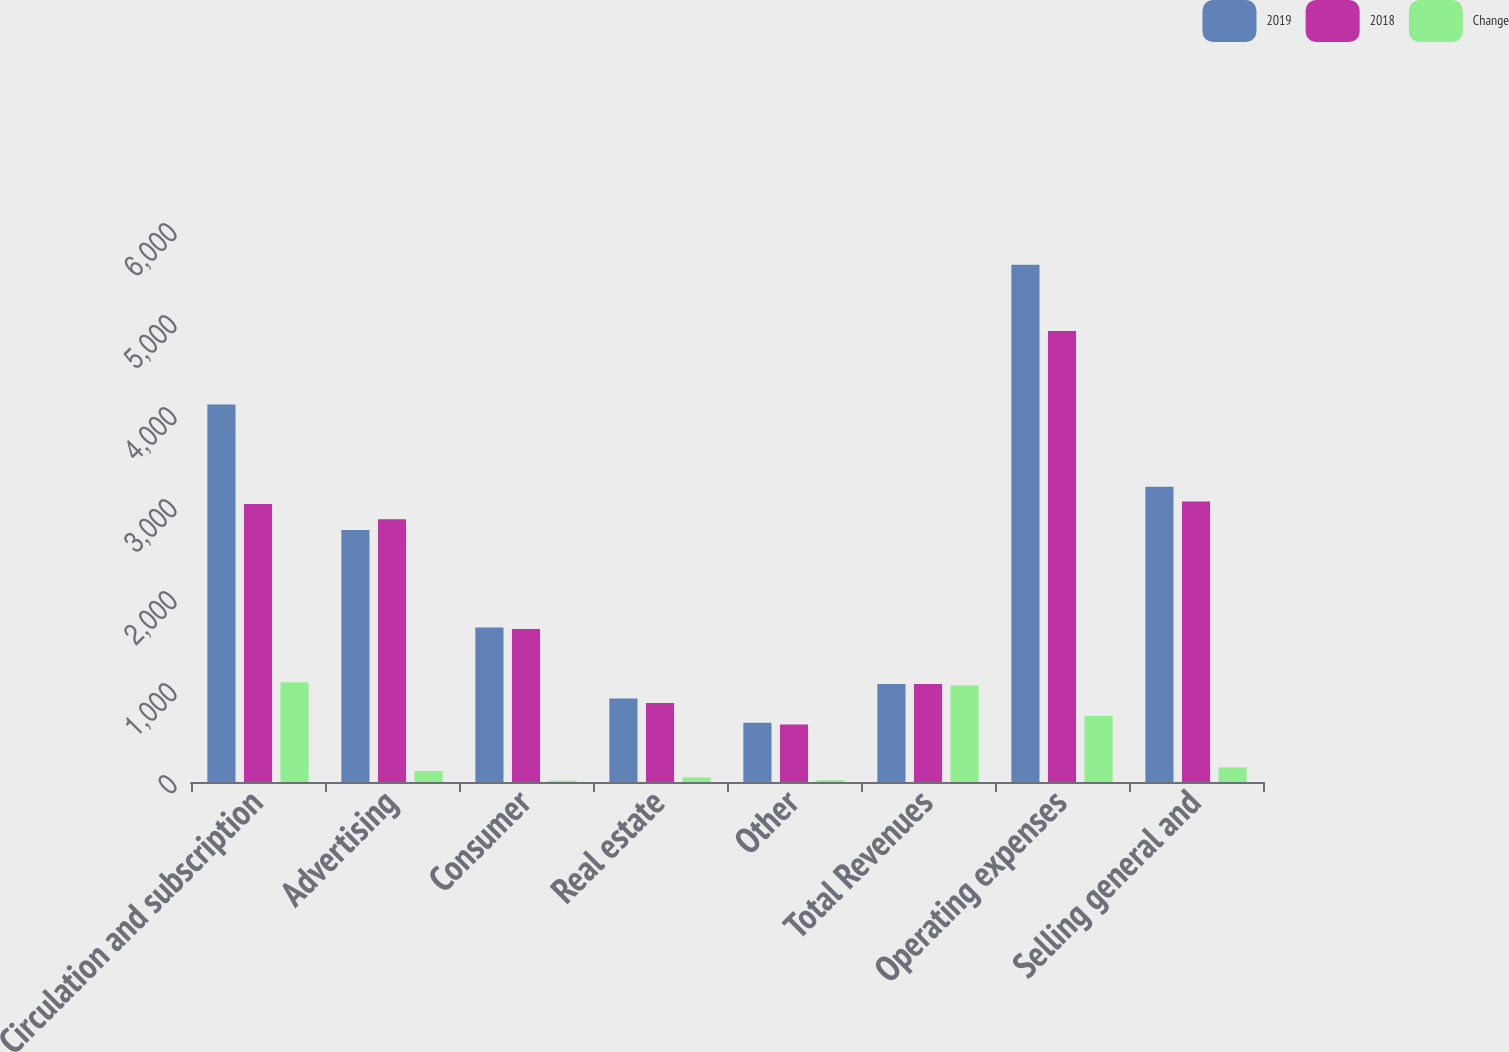Convert chart to OTSL. <chart><loc_0><loc_0><loc_500><loc_500><stacked_bar_chart><ecel><fcel>Circulation and subscription<fcel>Advertising<fcel>Consumer<fcel>Real estate<fcel>Other<fcel>Total Revenues<fcel>Operating expenses<fcel>Selling general and<nl><fcel>2019<fcel>4104<fcel>2738<fcel>1679<fcel>908<fcel>645<fcel>1066.5<fcel>5622<fcel>3208<nl><fcel>2018<fcel>3021<fcel>2856<fcel>1664<fcel>858<fcel>625<fcel>1066.5<fcel>4903<fcel>3050<nl><fcel>Change<fcel>1083<fcel>118<fcel>15<fcel>50<fcel>20<fcel>1050<fcel>719<fcel>158<nl></chart> 